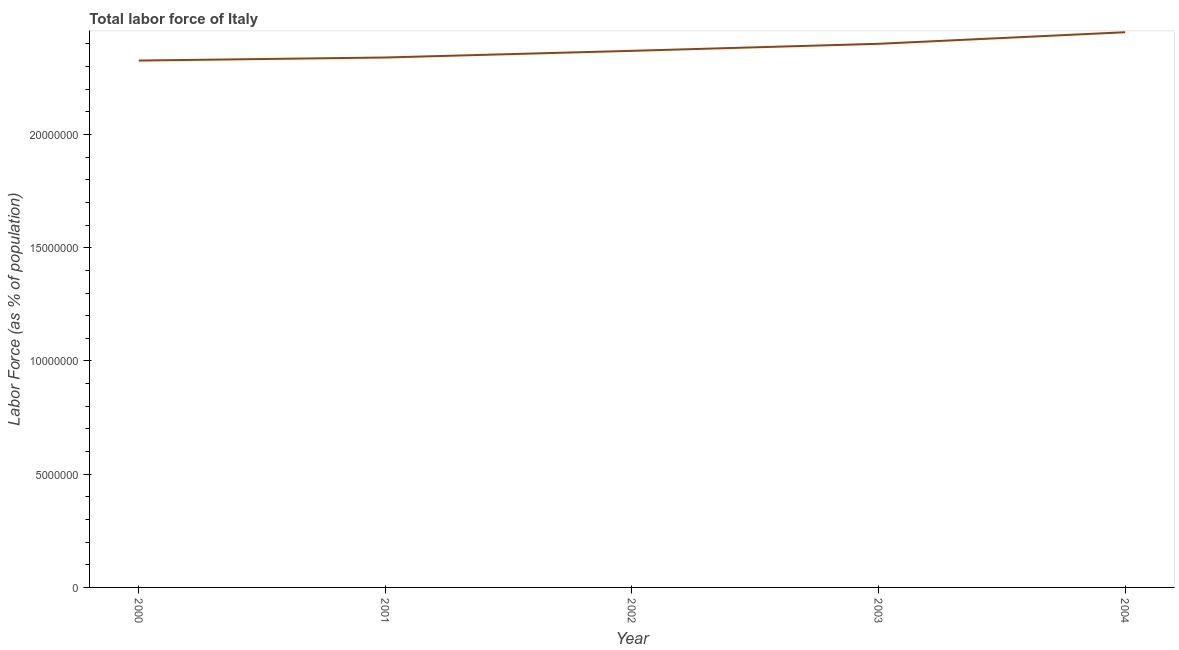What is the total labor force in 2004?
Make the answer very short. 2.45e+07. Across all years, what is the maximum total labor force?
Give a very brief answer. 2.45e+07. Across all years, what is the minimum total labor force?
Offer a very short reply. 2.33e+07. In which year was the total labor force maximum?
Ensure brevity in your answer.  2004. What is the sum of the total labor force?
Your answer should be very brief. 1.19e+08. What is the difference between the total labor force in 2000 and 2002?
Give a very brief answer. -4.30e+05. What is the average total labor force per year?
Make the answer very short. 2.38e+07. What is the median total labor force?
Provide a short and direct response. 2.37e+07. What is the ratio of the total labor force in 2002 to that in 2003?
Make the answer very short. 0.99. Is the difference between the total labor force in 2000 and 2003 greater than the difference between any two years?
Offer a very short reply. No. What is the difference between the highest and the second highest total labor force?
Keep it short and to the point. 5.10e+05. What is the difference between the highest and the lowest total labor force?
Provide a succinct answer. 1.25e+06. How many lines are there?
Ensure brevity in your answer.  1. Are the values on the major ticks of Y-axis written in scientific E-notation?
Provide a short and direct response. No. Does the graph contain any zero values?
Make the answer very short. No. What is the title of the graph?
Provide a succinct answer. Total labor force of Italy. What is the label or title of the Y-axis?
Offer a very short reply. Labor Force (as % of population). What is the Labor Force (as % of population) in 2000?
Make the answer very short. 2.33e+07. What is the Labor Force (as % of population) of 2001?
Provide a succinct answer. 2.34e+07. What is the Labor Force (as % of population) in 2002?
Your response must be concise. 2.37e+07. What is the Labor Force (as % of population) of 2003?
Your answer should be compact. 2.40e+07. What is the Labor Force (as % of population) in 2004?
Offer a very short reply. 2.45e+07. What is the difference between the Labor Force (as % of population) in 2000 and 2001?
Offer a terse response. -1.35e+05. What is the difference between the Labor Force (as % of population) in 2000 and 2002?
Make the answer very short. -4.30e+05. What is the difference between the Labor Force (as % of population) in 2000 and 2003?
Make the answer very short. -7.40e+05. What is the difference between the Labor Force (as % of population) in 2000 and 2004?
Offer a very short reply. -1.25e+06. What is the difference between the Labor Force (as % of population) in 2001 and 2002?
Give a very brief answer. -2.94e+05. What is the difference between the Labor Force (as % of population) in 2001 and 2003?
Your response must be concise. -6.05e+05. What is the difference between the Labor Force (as % of population) in 2001 and 2004?
Your response must be concise. -1.12e+06. What is the difference between the Labor Force (as % of population) in 2002 and 2003?
Offer a terse response. -3.11e+05. What is the difference between the Labor Force (as % of population) in 2002 and 2004?
Make the answer very short. -8.21e+05. What is the difference between the Labor Force (as % of population) in 2003 and 2004?
Provide a short and direct response. -5.10e+05. What is the ratio of the Labor Force (as % of population) in 2000 to that in 2004?
Make the answer very short. 0.95. What is the ratio of the Labor Force (as % of population) in 2001 to that in 2002?
Your answer should be very brief. 0.99. What is the ratio of the Labor Force (as % of population) in 2001 to that in 2004?
Give a very brief answer. 0.95. What is the ratio of the Labor Force (as % of population) in 2002 to that in 2003?
Provide a succinct answer. 0.99. What is the ratio of the Labor Force (as % of population) in 2002 to that in 2004?
Give a very brief answer. 0.97. What is the ratio of the Labor Force (as % of population) in 2003 to that in 2004?
Offer a terse response. 0.98. 